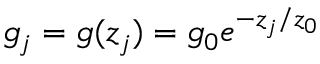Convert formula to latex. <formula><loc_0><loc_0><loc_500><loc_500>g _ { j } = g ( z _ { j } ) = g _ { 0 } e ^ { - z _ { j } / z _ { 0 } }</formula> 